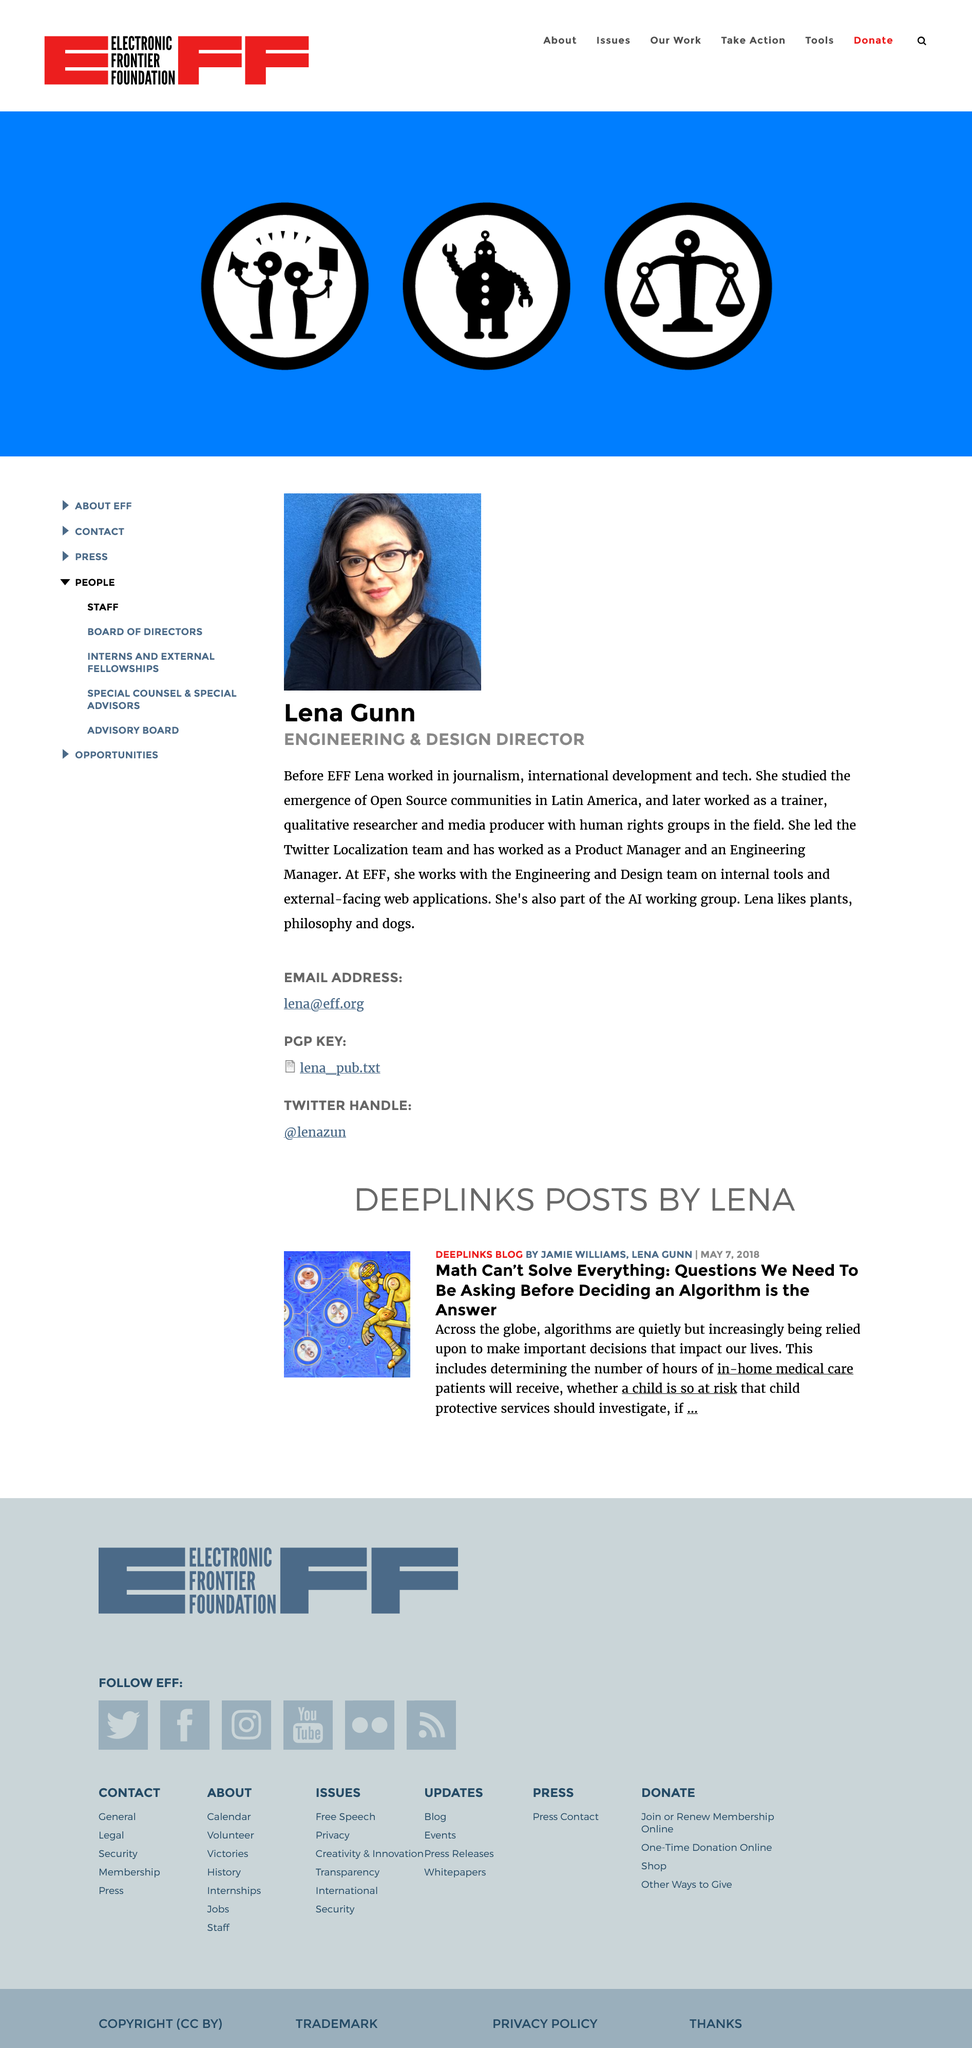Identify some key points in this picture. The speaker studied the emergence of Open Source communities in Latin America. Lena is a member of the AI working group and is actively involved in the group's activities. Lena Dunn holds the title of Engineering and Design Director in her professional role. 